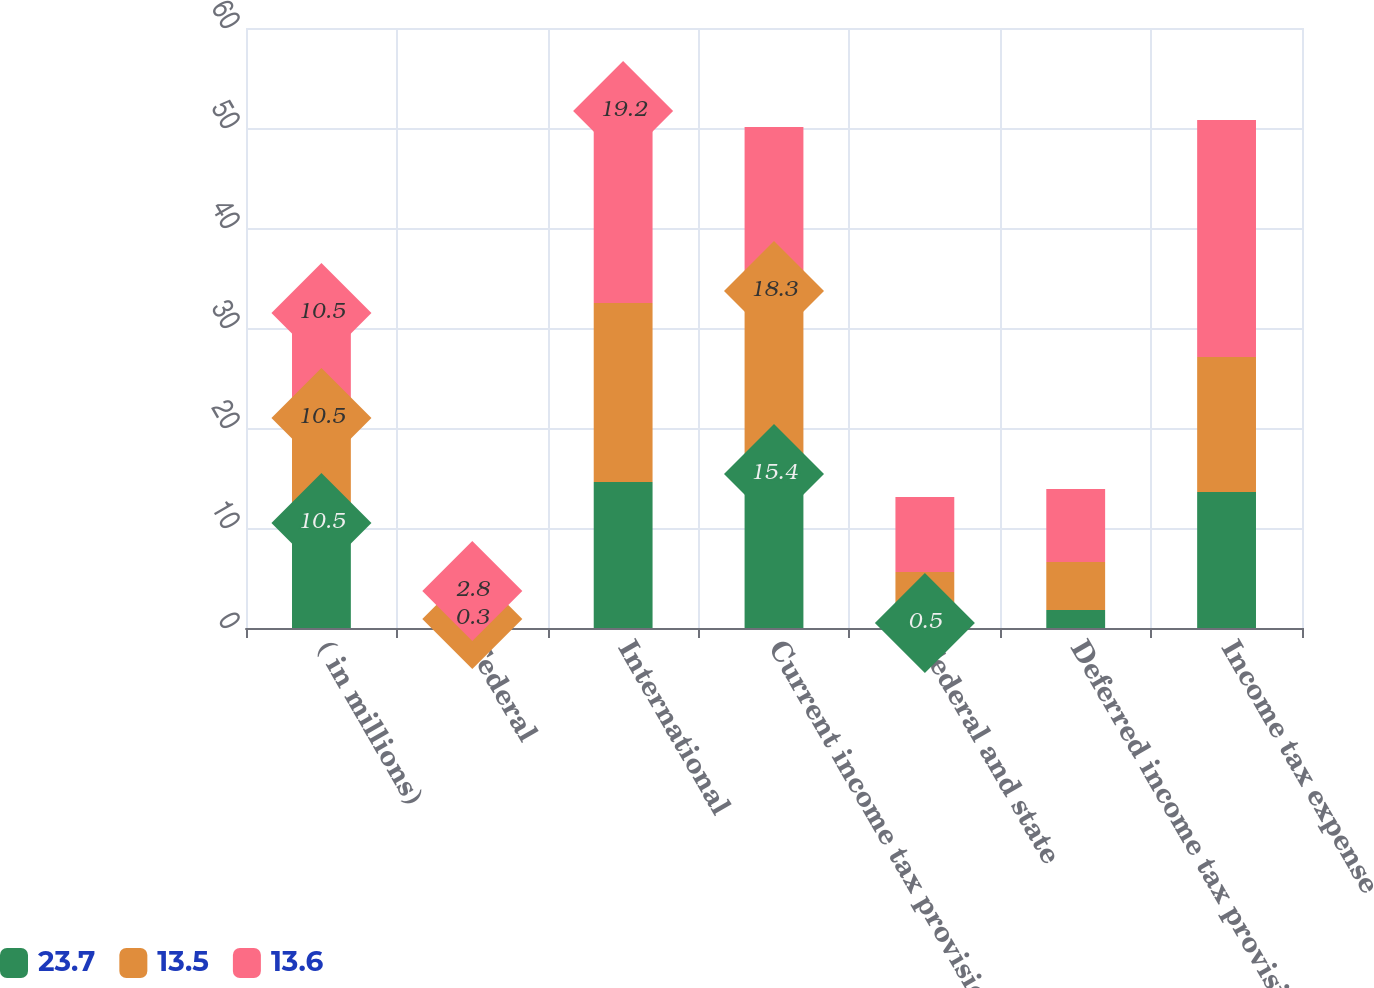Convert chart. <chart><loc_0><loc_0><loc_500><loc_500><stacked_bar_chart><ecel><fcel>( in millions)<fcel>Federal<fcel>International<fcel>Current income tax provision<fcel>Federal and state<fcel>Deferred income tax provision<fcel>Income tax expense<nl><fcel>23.7<fcel>10.5<fcel>0.6<fcel>14.6<fcel>15.4<fcel>0.5<fcel>1.8<fcel>13.6<nl><fcel>13.5<fcel>10.5<fcel>0.3<fcel>17.9<fcel>18.3<fcel>5.1<fcel>4.8<fcel>13.5<nl><fcel>13.6<fcel>10.5<fcel>2.8<fcel>19.2<fcel>16.4<fcel>7.5<fcel>7.3<fcel>23.7<nl></chart> 